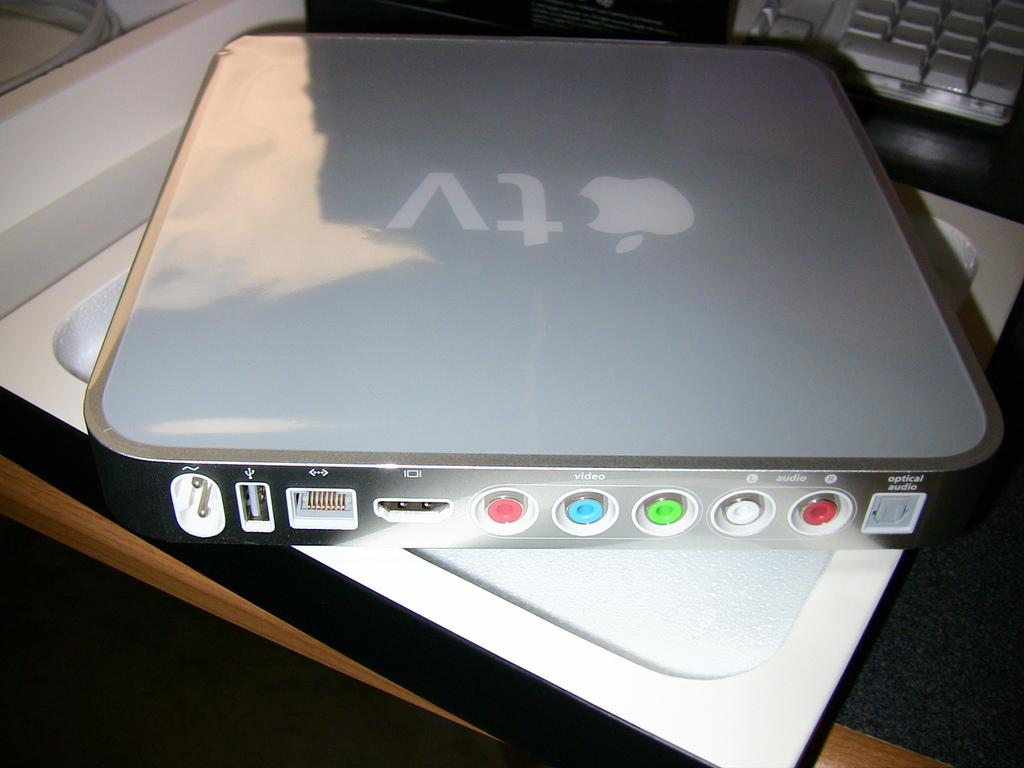<image>
Summarize the visual content of the image. A device displays the Apple TV logo on its top, and has three video cord ports. 